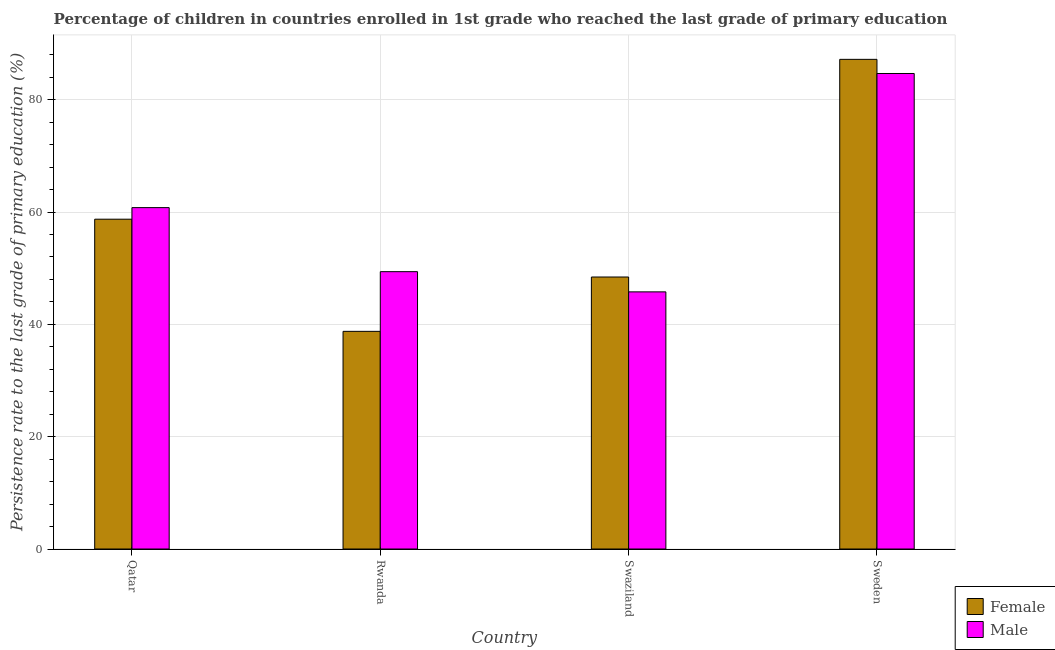Are the number of bars on each tick of the X-axis equal?
Offer a very short reply. Yes. How many bars are there on the 2nd tick from the right?
Provide a succinct answer. 2. What is the label of the 3rd group of bars from the left?
Provide a succinct answer. Swaziland. What is the persistence rate of female students in Qatar?
Your answer should be compact. 58.73. Across all countries, what is the maximum persistence rate of female students?
Your response must be concise. 87.19. Across all countries, what is the minimum persistence rate of female students?
Offer a very short reply. 38.76. In which country was the persistence rate of male students minimum?
Give a very brief answer. Swaziland. What is the total persistence rate of female students in the graph?
Give a very brief answer. 233.12. What is the difference between the persistence rate of male students in Rwanda and that in Sweden?
Keep it short and to the point. -35.29. What is the difference between the persistence rate of female students in Qatar and the persistence rate of male students in Sweden?
Provide a short and direct response. -25.95. What is the average persistence rate of male students per country?
Offer a very short reply. 60.16. What is the difference between the persistence rate of male students and persistence rate of female students in Sweden?
Your answer should be very brief. -2.52. In how many countries, is the persistence rate of female students greater than 84 %?
Keep it short and to the point. 1. What is the ratio of the persistence rate of male students in Qatar to that in Swaziland?
Keep it short and to the point. 1.33. Is the difference between the persistence rate of male students in Qatar and Rwanda greater than the difference between the persistence rate of female students in Qatar and Rwanda?
Offer a very short reply. No. What is the difference between the highest and the second highest persistence rate of male students?
Your response must be concise. 23.88. What is the difference between the highest and the lowest persistence rate of male students?
Ensure brevity in your answer.  38.89. What does the 2nd bar from the right in Swaziland represents?
Keep it short and to the point. Female. What is the difference between two consecutive major ticks on the Y-axis?
Your answer should be very brief. 20. Does the graph contain any zero values?
Provide a succinct answer. No. Where does the legend appear in the graph?
Offer a very short reply. Bottom right. How many legend labels are there?
Give a very brief answer. 2. What is the title of the graph?
Provide a succinct answer. Percentage of children in countries enrolled in 1st grade who reached the last grade of primary education. What is the label or title of the Y-axis?
Offer a terse response. Persistence rate to the last grade of primary education (%). What is the Persistence rate to the last grade of primary education (%) of Female in Qatar?
Your answer should be compact. 58.73. What is the Persistence rate to the last grade of primary education (%) in Male in Qatar?
Provide a short and direct response. 60.79. What is the Persistence rate to the last grade of primary education (%) in Female in Rwanda?
Keep it short and to the point. 38.76. What is the Persistence rate to the last grade of primary education (%) in Male in Rwanda?
Your answer should be very brief. 49.39. What is the Persistence rate to the last grade of primary education (%) of Female in Swaziland?
Give a very brief answer. 48.44. What is the Persistence rate to the last grade of primary education (%) of Male in Swaziland?
Your response must be concise. 45.79. What is the Persistence rate to the last grade of primary education (%) in Female in Sweden?
Your answer should be compact. 87.19. What is the Persistence rate to the last grade of primary education (%) of Male in Sweden?
Make the answer very short. 84.68. Across all countries, what is the maximum Persistence rate to the last grade of primary education (%) in Female?
Offer a very short reply. 87.19. Across all countries, what is the maximum Persistence rate to the last grade of primary education (%) of Male?
Provide a succinct answer. 84.68. Across all countries, what is the minimum Persistence rate to the last grade of primary education (%) of Female?
Provide a succinct answer. 38.76. Across all countries, what is the minimum Persistence rate to the last grade of primary education (%) of Male?
Keep it short and to the point. 45.79. What is the total Persistence rate to the last grade of primary education (%) in Female in the graph?
Your response must be concise. 233.12. What is the total Persistence rate to the last grade of primary education (%) in Male in the graph?
Provide a short and direct response. 240.65. What is the difference between the Persistence rate to the last grade of primary education (%) of Female in Qatar and that in Rwanda?
Your answer should be very brief. 19.97. What is the difference between the Persistence rate to the last grade of primary education (%) of Male in Qatar and that in Rwanda?
Ensure brevity in your answer.  11.4. What is the difference between the Persistence rate to the last grade of primary education (%) of Female in Qatar and that in Swaziland?
Give a very brief answer. 10.29. What is the difference between the Persistence rate to the last grade of primary education (%) of Male in Qatar and that in Swaziland?
Provide a short and direct response. 15. What is the difference between the Persistence rate to the last grade of primary education (%) in Female in Qatar and that in Sweden?
Make the answer very short. -28.46. What is the difference between the Persistence rate to the last grade of primary education (%) of Male in Qatar and that in Sweden?
Your response must be concise. -23.88. What is the difference between the Persistence rate to the last grade of primary education (%) in Female in Rwanda and that in Swaziland?
Offer a very short reply. -9.68. What is the difference between the Persistence rate to the last grade of primary education (%) in Male in Rwanda and that in Swaziland?
Provide a short and direct response. 3.6. What is the difference between the Persistence rate to the last grade of primary education (%) in Female in Rwanda and that in Sweden?
Keep it short and to the point. -48.44. What is the difference between the Persistence rate to the last grade of primary education (%) of Male in Rwanda and that in Sweden?
Your answer should be very brief. -35.29. What is the difference between the Persistence rate to the last grade of primary education (%) of Female in Swaziland and that in Sweden?
Your answer should be very brief. -38.76. What is the difference between the Persistence rate to the last grade of primary education (%) in Male in Swaziland and that in Sweden?
Provide a short and direct response. -38.89. What is the difference between the Persistence rate to the last grade of primary education (%) in Female in Qatar and the Persistence rate to the last grade of primary education (%) in Male in Rwanda?
Make the answer very short. 9.34. What is the difference between the Persistence rate to the last grade of primary education (%) in Female in Qatar and the Persistence rate to the last grade of primary education (%) in Male in Swaziland?
Your answer should be compact. 12.94. What is the difference between the Persistence rate to the last grade of primary education (%) in Female in Qatar and the Persistence rate to the last grade of primary education (%) in Male in Sweden?
Your answer should be very brief. -25.95. What is the difference between the Persistence rate to the last grade of primary education (%) in Female in Rwanda and the Persistence rate to the last grade of primary education (%) in Male in Swaziland?
Your response must be concise. -7.03. What is the difference between the Persistence rate to the last grade of primary education (%) of Female in Rwanda and the Persistence rate to the last grade of primary education (%) of Male in Sweden?
Your answer should be very brief. -45.92. What is the difference between the Persistence rate to the last grade of primary education (%) of Female in Swaziland and the Persistence rate to the last grade of primary education (%) of Male in Sweden?
Your answer should be compact. -36.24. What is the average Persistence rate to the last grade of primary education (%) in Female per country?
Ensure brevity in your answer.  58.28. What is the average Persistence rate to the last grade of primary education (%) in Male per country?
Your response must be concise. 60.16. What is the difference between the Persistence rate to the last grade of primary education (%) of Female and Persistence rate to the last grade of primary education (%) of Male in Qatar?
Your response must be concise. -2.06. What is the difference between the Persistence rate to the last grade of primary education (%) in Female and Persistence rate to the last grade of primary education (%) in Male in Rwanda?
Keep it short and to the point. -10.63. What is the difference between the Persistence rate to the last grade of primary education (%) in Female and Persistence rate to the last grade of primary education (%) in Male in Swaziland?
Make the answer very short. 2.65. What is the difference between the Persistence rate to the last grade of primary education (%) of Female and Persistence rate to the last grade of primary education (%) of Male in Sweden?
Your answer should be compact. 2.52. What is the ratio of the Persistence rate to the last grade of primary education (%) of Female in Qatar to that in Rwanda?
Your answer should be very brief. 1.52. What is the ratio of the Persistence rate to the last grade of primary education (%) in Male in Qatar to that in Rwanda?
Give a very brief answer. 1.23. What is the ratio of the Persistence rate to the last grade of primary education (%) of Female in Qatar to that in Swaziland?
Offer a very short reply. 1.21. What is the ratio of the Persistence rate to the last grade of primary education (%) in Male in Qatar to that in Swaziland?
Your answer should be very brief. 1.33. What is the ratio of the Persistence rate to the last grade of primary education (%) in Female in Qatar to that in Sweden?
Make the answer very short. 0.67. What is the ratio of the Persistence rate to the last grade of primary education (%) in Male in Qatar to that in Sweden?
Keep it short and to the point. 0.72. What is the ratio of the Persistence rate to the last grade of primary education (%) in Female in Rwanda to that in Swaziland?
Give a very brief answer. 0.8. What is the ratio of the Persistence rate to the last grade of primary education (%) of Male in Rwanda to that in Swaziland?
Make the answer very short. 1.08. What is the ratio of the Persistence rate to the last grade of primary education (%) in Female in Rwanda to that in Sweden?
Provide a succinct answer. 0.44. What is the ratio of the Persistence rate to the last grade of primary education (%) of Male in Rwanda to that in Sweden?
Ensure brevity in your answer.  0.58. What is the ratio of the Persistence rate to the last grade of primary education (%) in Female in Swaziland to that in Sweden?
Give a very brief answer. 0.56. What is the ratio of the Persistence rate to the last grade of primary education (%) in Male in Swaziland to that in Sweden?
Provide a succinct answer. 0.54. What is the difference between the highest and the second highest Persistence rate to the last grade of primary education (%) of Female?
Provide a succinct answer. 28.46. What is the difference between the highest and the second highest Persistence rate to the last grade of primary education (%) of Male?
Offer a terse response. 23.88. What is the difference between the highest and the lowest Persistence rate to the last grade of primary education (%) in Female?
Offer a terse response. 48.44. What is the difference between the highest and the lowest Persistence rate to the last grade of primary education (%) in Male?
Give a very brief answer. 38.89. 